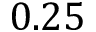<formula> <loc_0><loc_0><loc_500><loc_500>0 . 2 5</formula> 